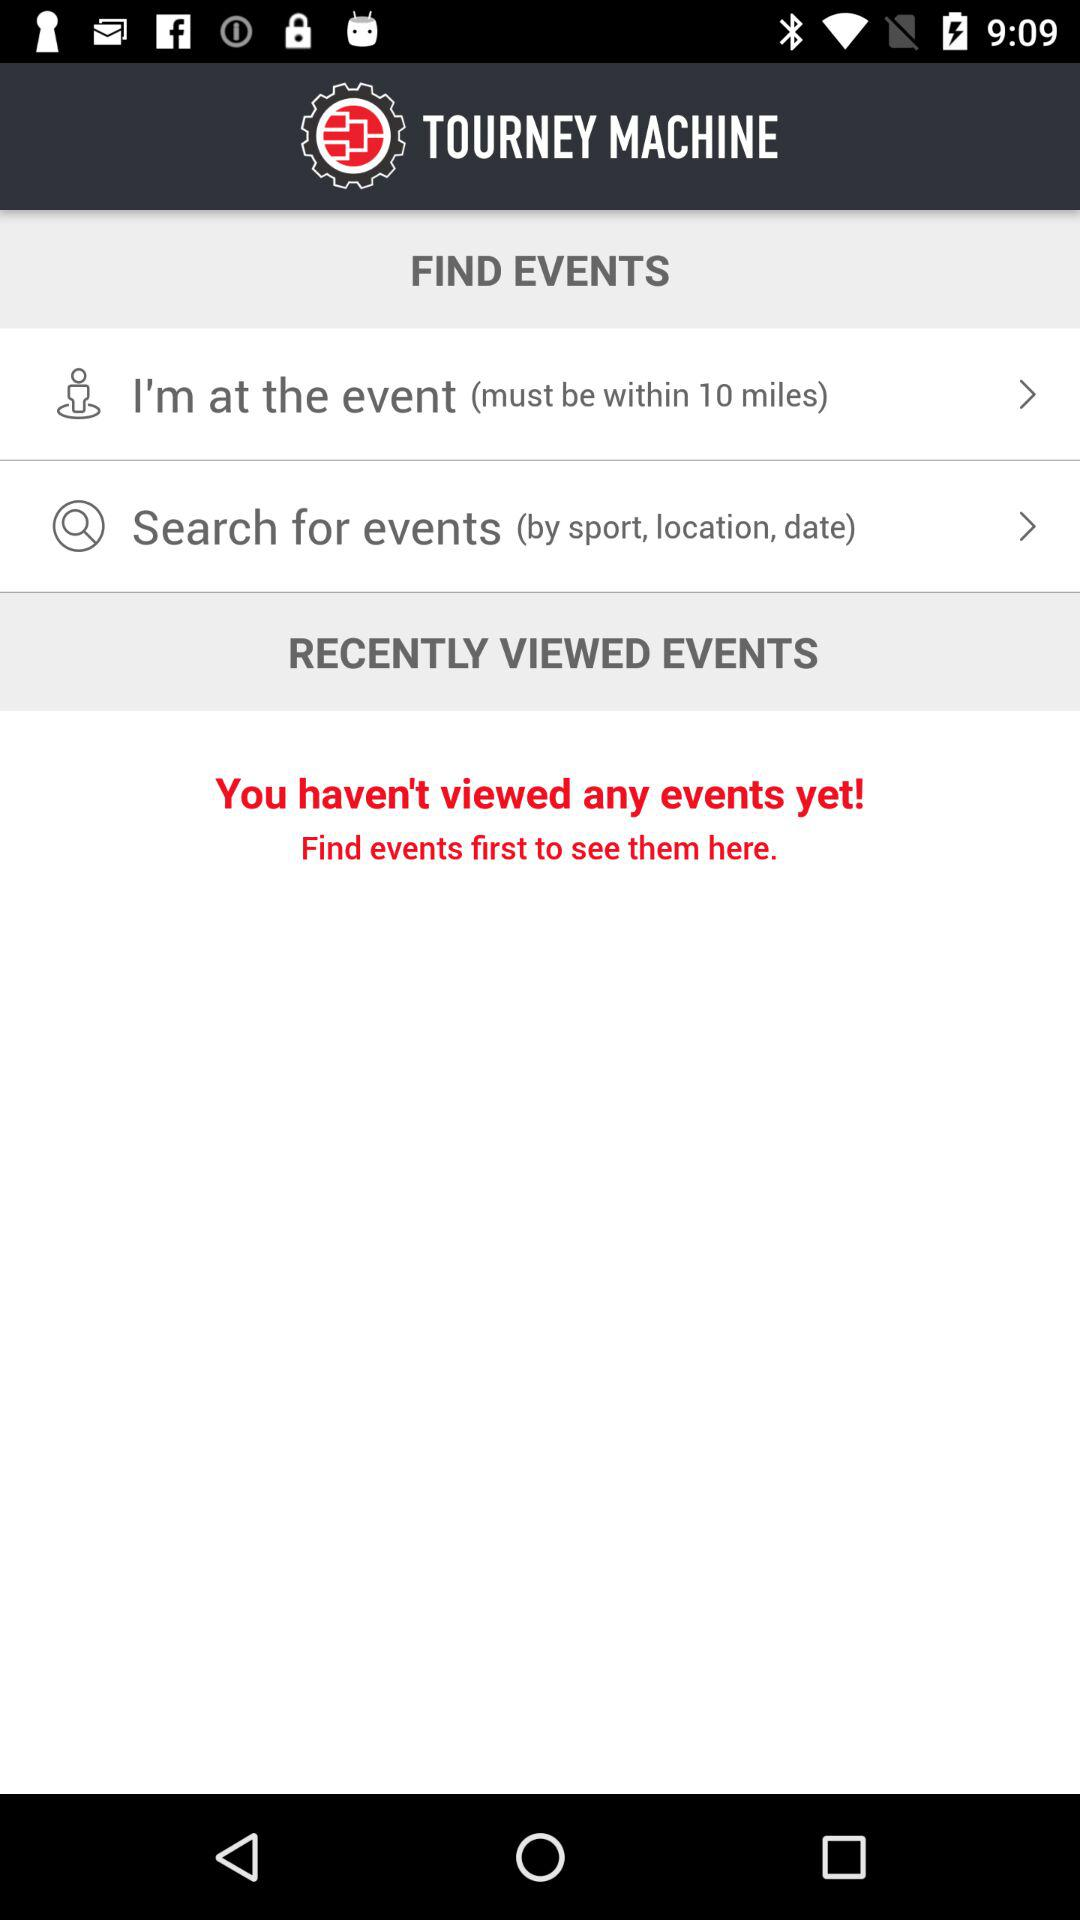Which events are close by?
When the provided information is insufficient, respond with <no answer>. <no answer> 